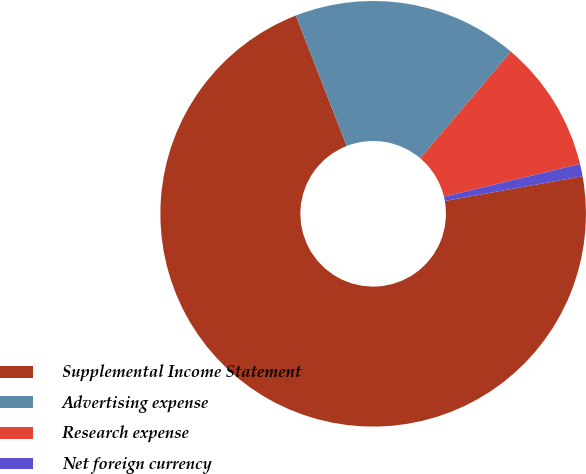Convert chart. <chart><loc_0><loc_0><loc_500><loc_500><pie_chart><fcel>Supplemental Income Statement<fcel>Advertising expense<fcel>Research expense<fcel>Net foreign currency<nl><fcel>71.9%<fcel>17.13%<fcel>10.03%<fcel>0.94%<nl></chart> 